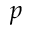Convert formula to latex. <formula><loc_0><loc_0><loc_500><loc_500>p</formula> 